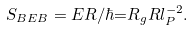<formula> <loc_0><loc_0><loc_500><loc_500>S _ { B E B } = E R / \hbar { = } R _ { g } R l _ { P } ^ { - 2 } .</formula> 